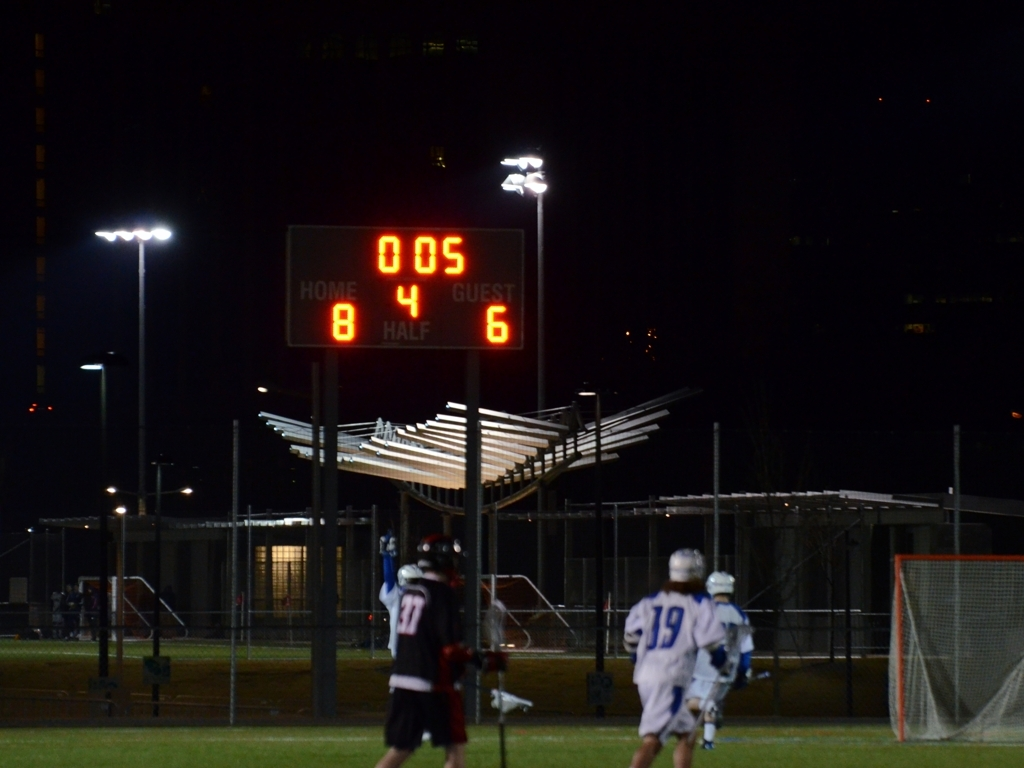Can you describe the atmosphere of this event? The image captures a nighttime sports event under bright lights with a scoreboard showing the home team ahead with a score of 8 versus the guest team's 6. The ambient lighting and scoreboard help to convey a competitive and energetic atmosphere. The presence of spectators would likely add to the environment, although we cannot see them in this frame. 